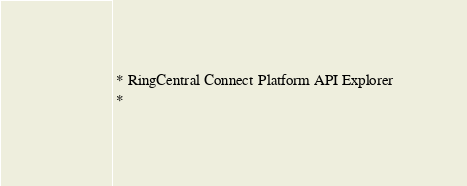<code> <loc_0><loc_0><loc_500><loc_500><_Go_> * RingCentral Connect Platform API Explorer
 *</code> 